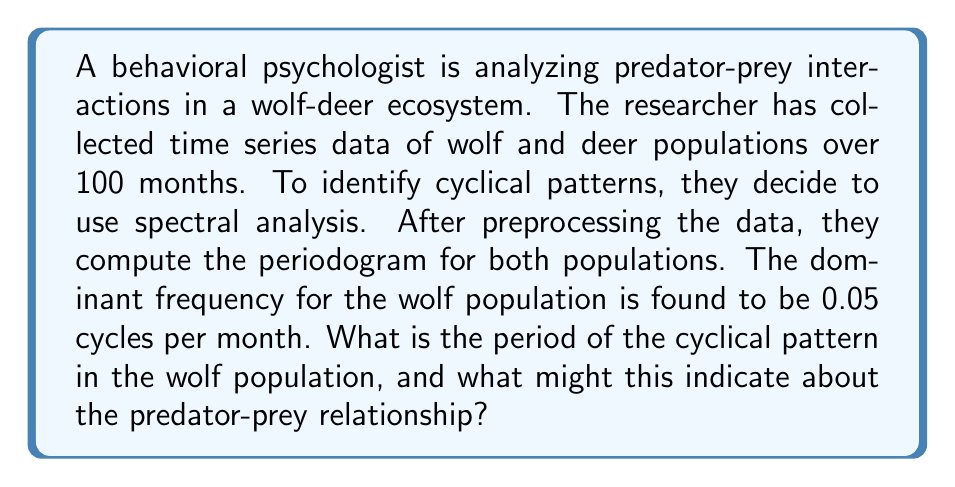What is the answer to this math problem? To solve this problem, we need to understand the relationship between frequency and period in spectral analysis:

1) The frequency (f) is given in cycles per month, which is the reciprocal of the period (T) in months:

   $$f = \frac{1}{T}$$

2) We are given that the dominant frequency is 0.05 cycles per month. Let's substitute this into our equation:

   $$0.05 = \frac{1}{T}$$

3) To find T, we need to take the reciprocal of both sides:

   $$T = \frac{1}{0.05} = 20$$

4) Therefore, the period of the cyclical pattern is 20 months.

Interpretation:
This 20-month cycle in the wolf population likely reflects the predator-prey dynamics with the deer population. In predator-prey systems, we often observe cyclical patterns due to the following mechanism:

- As prey (deer) population increases, predator (wolf) population follows with a slight delay.
- The increased predator population then causes a decrease in prey population.
- With fewer prey, the predator population subsequently decreases.
- This allows the prey population to recover, and the cycle begins again.

The 20-month period suggests that it takes about 1.67 years for this cycle to complete. This information can be valuable for wildlife management and understanding the ecosystem's dynamics.

It's important to note that we would also want to analyze the deer population's periodogram to see if it shows a similar cyclical pattern, possibly with a phase shift relative to the wolf population.
Answer: The period of the cyclical pattern in the wolf population is 20 months. This indicates a regular fluctuation in the wolf population likely driven by predator-prey dynamics with the deer population, completing a full cycle approximately every 1.67 years. 